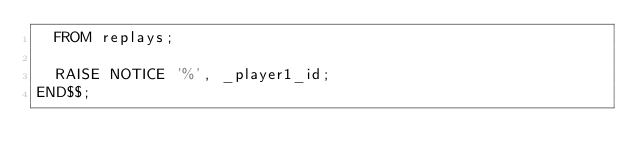<code> <loc_0><loc_0><loc_500><loc_500><_SQL_>  FROM replays;

  RAISE NOTICE '%', _player1_id;
END$$;
</code> 